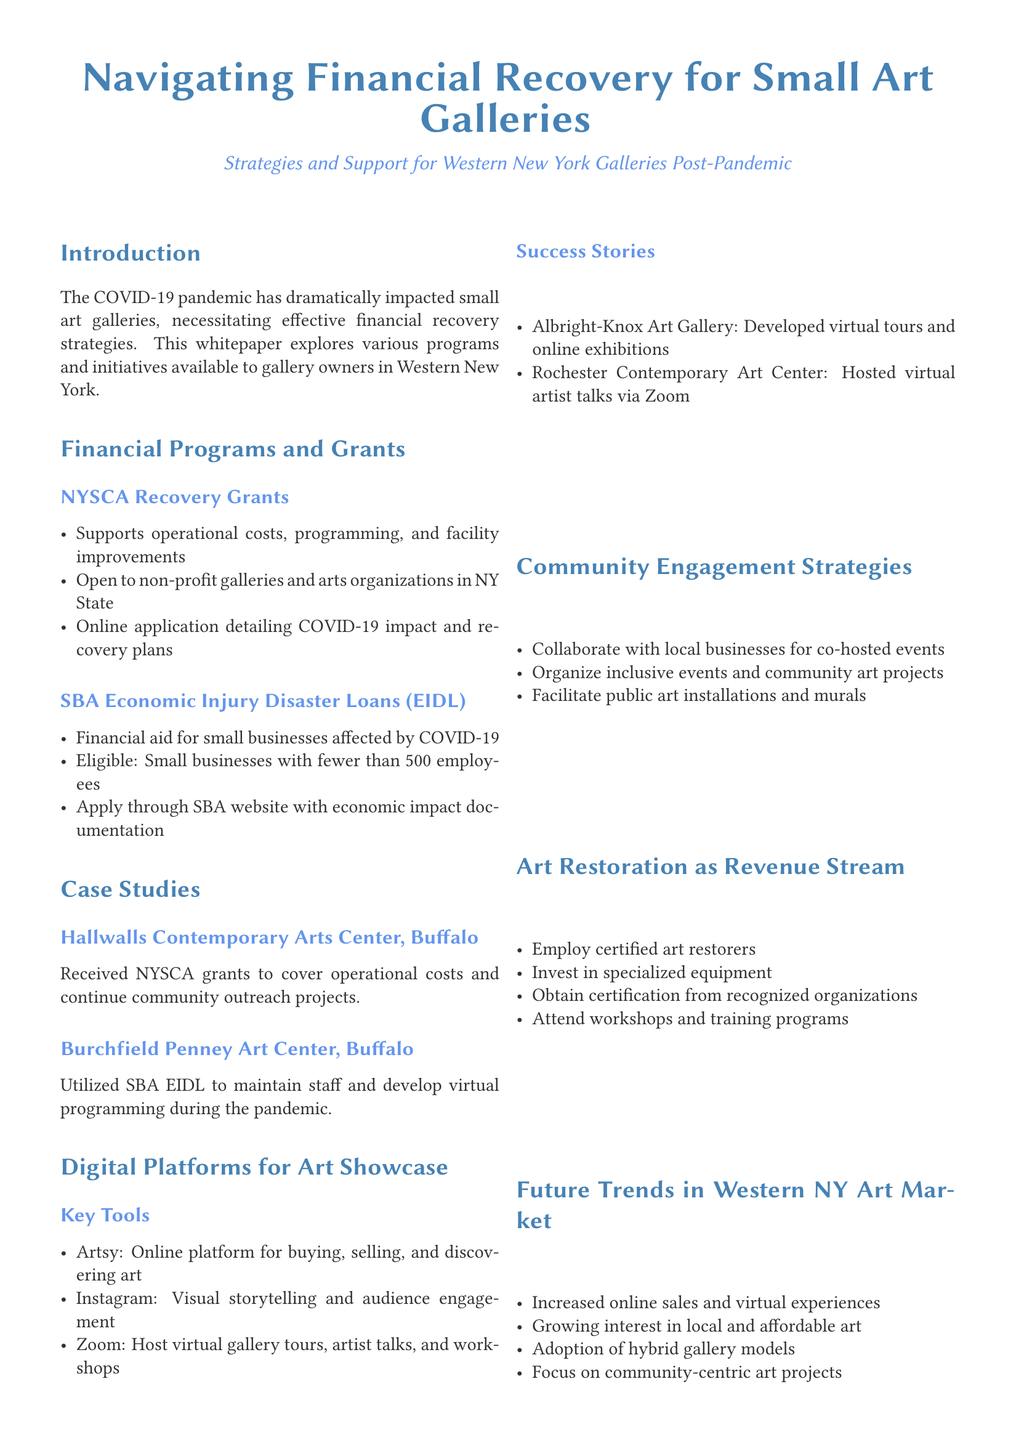What is the name of the grant mentioned for supporting operational costs? The grant mentioned for supporting operational costs is the NYSCA Recovery Grants.
Answer: NYSCA Recovery Grants What type of businesses are eligible for SBA Economic Injury Disaster Loans? Eligible businesses for SBA EIDL are small businesses with fewer than 500 employees.
Answer: Small businesses with fewer than 500 employees Which platform is suggested for virtual gallery tours? The platform suggested for virtual gallery tours is Zoom.
Answer: Zoom What is one key strategy for community engagement mentioned? One key strategy for community engagement mentioned is to collaborate with local businesses for co-hosted events.
Answer: Collaborate with local businesses for co-hosted events Which art center received NYSCA grants? The art center that received NYSCA grants is Hallwalls Contemporary Arts Center.
Answer: Hallwalls Contemporary Arts Center What is a recommended investment for art restoration services? A recommended investment for art restoration services is specialized equipment.
Answer: Specialized equipment What is one future trend in the Western NY art market? One future trend in the Western NY art market is increased online sales and virtual experiences.
Answer: Increased online sales and virtual experiences What phrase describes the whitepaper's focus? The phrase that describes the whitepaper's focus is navigating financial recovery for small art galleries post-pandemic.
Answer: Navigating financial recovery for small art galleries post-pandemic 